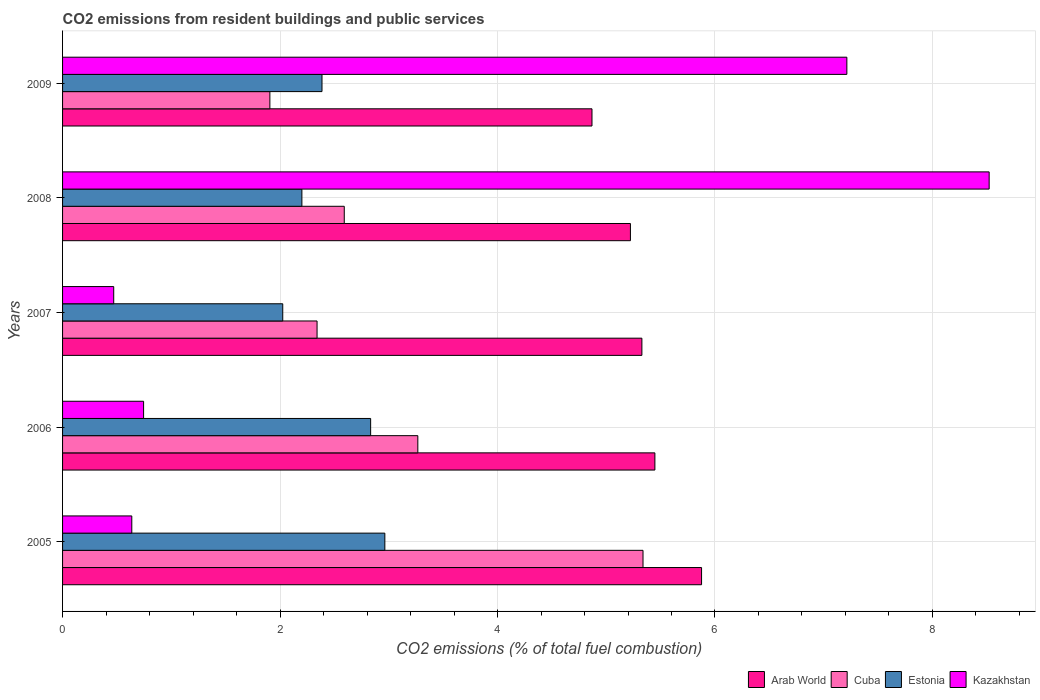How many different coloured bars are there?
Provide a succinct answer. 4. How many groups of bars are there?
Provide a succinct answer. 5. Are the number of bars per tick equal to the number of legend labels?
Provide a succinct answer. Yes. Are the number of bars on each tick of the Y-axis equal?
Offer a very short reply. Yes. How many bars are there on the 2nd tick from the top?
Your answer should be very brief. 4. In how many cases, is the number of bars for a given year not equal to the number of legend labels?
Offer a very short reply. 0. What is the total CO2 emitted in Arab World in 2008?
Keep it short and to the point. 5.22. Across all years, what is the maximum total CO2 emitted in Arab World?
Offer a very short reply. 5.88. Across all years, what is the minimum total CO2 emitted in Arab World?
Provide a short and direct response. 4.87. In which year was the total CO2 emitted in Kazakhstan maximum?
Provide a short and direct response. 2008. What is the total total CO2 emitted in Cuba in the graph?
Offer a terse response. 15.44. What is the difference between the total CO2 emitted in Arab World in 2005 and that in 2007?
Make the answer very short. 0.55. What is the difference between the total CO2 emitted in Estonia in 2009 and the total CO2 emitted in Cuba in 2007?
Your answer should be very brief. 0.05. What is the average total CO2 emitted in Arab World per year?
Offer a very short reply. 5.35. In the year 2009, what is the difference between the total CO2 emitted in Estonia and total CO2 emitted in Cuba?
Ensure brevity in your answer.  0.48. What is the ratio of the total CO2 emitted in Arab World in 2006 to that in 2008?
Provide a short and direct response. 1.04. Is the total CO2 emitted in Cuba in 2007 less than that in 2008?
Offer a terse response. Yes. Is the difference between the total CO2 emitted in Estonia in 2008 and 2009 greater than the difference between the total CO2 emitted in Cuba in 2008 and 2009?
Make the answer very short. No. What is the difference between the highest and the second highest total CO2 emitted in Kazakhstan?
Your answer should be very brief. 1.31. What is the difference between the highest and the lowest total CO2 emitted in Estonia?
Give a very brief answer. 0.94. In how many years, is the total CO2 emitted in Estonia greater than the average total CO2 emitted in Estonia taken over all years?
Provide a succinct answer. 2. Is it the case that in every year, the sum of the total CO2 emitted in Cuba and total CO2 emitted in Arab World is greater than the sum of total CO2 emitted in Kazakhstan and total CO2 emitted in Estonia?
Make the answer very short. Yes. What does the 2nd bar from the top in 2007 represents?
Your answer should be compact. Estonia. What does the 2nd bar from the bottom in 2009 represents?
Make the answer very short. Cuba. Is it the case that in every year, the sum of the total CO2 emitted in Estonia and total CO2 emitted in Kazakhstan is greater than the total CO2 emitted in Cuba?
Ensure brevity in your answer.  No. How many years are there in the graph?
Keep it short and to the point. 5. What is the difference between two consecutive major ticks on the X-axis?
Give a very brief answer. 2. Does the graph contain any zero values?
Give a very brief answer. No. Where does the legend appear in the graph?
Offer a terse response. Bottom right. What is the title of the graph?
Provide a short and direct response. CO2 emissions from resident buildings and public services. Does "Cyprus" appear as one of the legend labels in the graph?
Offer a very short reply. No. What is the label or title of the X-axis?
Give a very brief answer. CO2 emissions (% of total fuel combustion). What is the CO2 emissions (% of total fuel combustion) in Arab World in 2005?
Make the answer very short. 5.88. What is the CO2 emissions (% of total fuel combustion) of Cuba in 2005?
Ensure brevity in your answer.  5.34. What is the CO2 emissions (% of total fuel combustion) in Estonia in 2005?
Keep it short and to the point. 2.96. What is the CO2 emissions (% of total fuel combustion) in Kazakhstan in 2005?
Keep it short and to the point. 0.64. What is the CO2 emissions (% of total fuel combustion) of Arab World in 2006?
Give a very brief answer. 5.45. What is the CO2 emissions (% of total fuel combustion) of Cuba in 2006?
Offer a terse response. 3.27. What is the CO2 emissions (% of total fuel combustion) of Estonia in 2006?
Provide a short and direct response. 2.83. What is the CO2 emissions (% of total fuel combustion) in Kazakhstan in 2006?
Keep it short and to the point. 0.75. What is the CO2 emissions (% of total fuel combustion) of Arab World in 2007?
Offer a very short reply. 5.33. What is the CO2 emissions (% of total fuel combustion) in Cuba in 2007?
Your answer should be very brief. 2.34. What is the CO2 emissions (% of total fuel combustion) of Estonia in 2007?
Make the answer very short. 2.02. What is the CO2 emissions (% of total fuel combustion) of Kazakhstan in 2007?
Your answer should be very brief. 0.47. What is the CO2 emissions (% of total fuel combustion) of Arab World in 2008?
Provide a short and direct response. 5.22. What is the CO2 emissions (% of total fuel combustion) in Cuba in 2008?
Your answer should be compact. 2.59. What is the CO2 emissions (% of total fuel combustion) in Estonia in 2008?
Offer a terse response. 2.2. What is the CO2 emissions (% of total fuel combustion) of Kazakhstan in 2008?
Your answer should be compact. 8.52. What is the CO2 emissions (% of total fuel combustion) in Arab World in 2009?
Your answer should be compact. 4.87. What is the CO2 emissions (% of total fuel combustion) in Cuba in 2009?
Keep it short and to the point. 1.91. What is the CO2 emissions (% of total fuel combustion) of Estonia in 2009?
Offer a very short reply. 2.39. What is the CO2 emissions (% of total fuel combustion) of Kazakhstan in 2009?
Make the answer very short. 7.21. Across all years, what is the maximum CO2 emissions (% of total fuel combustion) of Arab World?
Give a very brief answer. 5.88. Across all years, what is the maximum CO2 emissions (% of total fuel combustion) in Cuba?
Provide a short and direct response. 5.34. Across all years, what is the maximum CO2 emissions (% of total fuel combustion) in Estonia?
Ensure brevity in your answer.  2.96. Across all years, what is the maximum CO2 emissions (% of total fuel combustion) of Kazakhstan?
Ensure brevity in your answer.  8.52. Across all years, what is the minimum CO2 emissions (% of total fuel combustion) of Arab World?
Your response must be concise. 4.87. Across all years, what is the minimum CO2 emissions (% of total fuel combustion) of Cuba?
Keep it short and to the point. 1.91. Across all years, what is the minimum CO2 emissions (% of total fuel combustion) of Estonia?
Provide a succinct answer. 2.02. Across all years, what is the minimum CO2 emissions (% of total fuel combustion) of Kazakhstan?
Your answer should be compact. 0.47. What is the total CO2 emissions (% of total fuel combustion) of Arab World in the graph?
Your response must be concise. 26.74. What is the total CO2 emissions (% of total fuel combustion) in Cuba in the graph?
Your response must be concise. 15.44. What is the total CO2 emissions (% of total fuel combustion) of Estonia in the graph?
Your answer should be very brief. 12.41. What is the total CO2 emissions (% of total fuel combustion) of Kazakhstan in the graph?
Your answer should be compact. 17.59. What is the difference between the CO2 emissions (% of total fuel combustion) in Arab World in 2005 and that in 2006?
Make the answer very short. 0.43. What is the difference between the CO2 emissions (% of total fuel combustion) in Cuba in 2005 and that in 2006?
Ensure brevity in your answer.  2.07. What is the difference between the CO2 emissions (% of total fuel combustion) in Estonia in 2005 and that in 2006?
Your response must be concise. 0.13. What is the difference between the CO2 emissions (% of total fuel combustion) of Kazakhstan in 2005 and that in 2006?
Offer a terse response. -0.11. What is the difference between the CO2 emissions (% of total fuel combustion) in Arab World in 2005 and that in 2007?
Give a very brief answer. 0.55. What is the difference between the CO2 emissions (% of total fuel combustion) of Cuba in 2005 and that in 2007?
Provide a short and direct response. 3. What is the difference between the CO2 emissions (% of total fuel combustion) of Estonia in 2005 and that in 2007?
Your answer should be very brief. 0.94. What is the difference between the CO2 emissions (% of total fuel combustion) in Kazakhstan in 2005 and that in 2007?
Your answer should be very brief. 0.17. What is the difference between the CO2 emissions (% of total fuel combustion) of Arab World in 2005 and that in 2008?
Provide a succinct answer. 0.65. What is the difference between the CO2 emissions (% of total fuel combustion) of Cuba in 2005 and that in 2008?
Keep it short and to the point. 2.75. What is the difference between the CO2 emissions (% of total fuel combustion) of Estonia in 2005 and that in 2008?
Keep it short and to the point. 0.76. What is the difference between the CO2 emissions (% of total fuel combustion) in Kazakhstan in 2005 and that in 2008?
Offer a very short reply. -7.88. What is the difference between the CO2 emissions (% of total fuel combustion) in Arab World in 2005 and that in 2009?
Offer a very short reply. 1.01. What is the difference between the CO2 emissions (% of total fuel combustion) of Cuba in 2005 and that in 2009?
Ensure brevity in your answer.  3.43. What is the difference between the CO2 emissions (% of total fuel combustion) in Estonia in 2005 and that in 2009?
Your response must be concise. 0.58. What is the difference between the CO2 emissions (% of total fuel combustion) in Kazakhstan in 2005 and that in 2009?
Give a very brief answer. -6.58. What is the difference between the CO2 emissions (% of total fuel combustion) of Arab World in 2006 and that in 2007?
Your response must be concise. 0.12. What is the difference between the CO2 emissions (% of total fuel combustion) of Cuba in 2006 and that in 2007?
Offer a very short reply. 0.93. What is the difference between the CO2 emissions (% of total fuel combustion) of Estonia in 2006 and that in 2007?
Your response must be concise. 0.81. What is the difference between the CO2 emissions (% of total fuel combustion) in Kazakhstan in 2006 and that in 2007?
Make the answer very short. 0.27. What is the difference between the CO2 emissions (% of total fuel combustion) of Arab World in 2006 and that in 2008?
Offer a very short reply. 0.23. What is the difference between the CO2 emissions (% of total fuel combustion) of Cuba in 2006 and that in 2008?
Offer a very short reply. 0.68. What is the difference between the CO2 emissions (% of total fuel combustion) in Estonia in 2006 and that in 2008?
Keep it short and to the point. 0.63. What is the difference between the CO2 emissions (% of total fuel combustion) in Kazakhstan in 2006 and that in 2008?
Your answer should be compact. -7.78. What is the difference between the CO2 emissions (% of total fuel combustion) in Arab World in 2006 and that in 2009?
Offer a very short reply. 0.58. What is the difference between the CO2 emissions (% of total fuel combustion) in Cuba in 2006 and that in 2009?
Give a very brief answer. 1.36. What is the difference between the CO2 emissions (% of total fuel combustion) in Estonia in 2006 and that in 2009?
Give a very brief answer. 0.45. What is the difference between the CO2 emissions (% of total fuel combustion) of Kazakhstan in 2006 and that in 2009?
Ensure brevity in your answer.  -6.47. What is the difference between the CO2 emissions (% of total fuel combustion) in Arab World in 2007 and that in 2008?
Offer a very short reply. 0.11. What is the difference between the CO2 emissions (% of total fuel combustion) of Cuba in 2007 and that in 2008?
Your response must be concise. -0.25. What is the difference between the CO2 emissions (% of total fuel combustion) in Estonia in 2007 and that in 2008?
Give a very brief answer. -0.18. What is the difference between the CO2 emissions (% of total fuel combustion) of Kazakhstan in 2007 and that in 2008?
Keep it short and to the point. -8.05. What is the difference between the CO2 emissions (% of total fuel combustion) of Arab World in 2007 and that in 2009?
Your answer should be very brief. 0.46. What is the difference between the CO2 emissions (% of total fuel combustion) in Cuba in 2007 and that in 2009?
Provide a succinct answer. 0.43. What is the difference between the CO2 emissions (% of total fuel combustion) in Estonia in 2007 and that in 2009?
Offer a very short reply. -0.36. What is the difference between the CO2 emissions (% of total fuel combustion) in Kazakhstan in 2007 and that in 2009?
Give a very brief answer. -6.74. What is the difference between the CO2 emissions (% of total fuel combustion) in Arab World in 2008 and that in 2009?
Your answer should be very brief. 0.35. What is the difference between the CO2 emissions (% of total fuel combustion) of Cuba in 2008 and that in 2009?
Keep it short and to the point. 0.68. What is the difference between the CO2 emissions (% of total fuel combustion) of Estonia in 2008 and that in 2009?
Provide a short and direct response. -0.18. What is the difference between the CO2 emissions (% of total fuel combustion) of Kazakhstan in 2008 and that in 2009?
Keep it short and to the point. 1.31. What is the difference between the CO2 emissions (% of total fuel combustion) of Arab World in 2005 and the CO2 emissions (% of total fuel combustion) of Cuba in 2006?
Provide a succinct answer. 2.61. What is the difference between the CO2 emissions (% of total fuel combustion) in Arab World in 2005 and the CO2 emissions (% of total fuel combustion) in Estonia in 2006?
Provide a short and direct response. 3.04. What is the difference between the CO2 emissions (% of total fuel combustion) in Arab World in 2005 and the CO2 emissions (% of total fuel combustion) in Kazakhstan in 2006?
Provide a succinct answer. 5.13. What is the difference between the CO2 emissions (% of total fuel combustion) of Cuba in 2005 and the CO2 emissions (% of total fuel combustion) of Estonia in 2006?
Offer a very short reply. 2.5. What is the difference between the CO2 emissions (% of total fuel combustion) of Cuba in 2005 and the CO2 emissions (% of total fuel combustion) of Kazakhstan in 2006?
Keep it short and to the point. 4.59. What is the difference between the CO2 emissions (% of total fuel combustion) in Estonia in 2005 and the CO2 emissions (% of total fuel combustion) in Kazakhstan in 2006?
Ensure brevity in your answer.  2.22. What is the difference between the CO2 emissions (% of total fuel combustion) in Arab World in 2005 and the CO2 emissions (% of total fuel combustion) in Cuba in 2007?
Give a very brief answer. 3.54. What is the difference between the CO2 emissions (% of total fuel combustion) of Arab World in 2005 and the CO2 emissions (% of total fuel combustion) of Estonia in 2007?
Ensure brevity in your answer.  3.85. What is the difference between the CO2 emissions (% of total fuel combustion) in Arab World in 2005 and the CO2 emissions (% of total fuel combustion) in Kazakhstan in 2007?
Provide a succinct answer. 5.41. What is the difference between the CO2 emissions (% of total fuel combustion) in Cuba in 2005 and the CO2 emissions (% of total fuel combustion) in Estonia in 2007?
Provide a succinct answer. 3.31. What is the difference between the CO2 emissions (% of total fuel combustion) in Cuba in 2005 and the CO2 emissions (% of total fuel combustion) in Kazakhstan in 2007?
Give a very brief answer. 4.87. What is the difference between the CO2 emissions (% of total fuel combustion) in Estonia in 2005 and the CO2 emissions (% of total fuel combustion) in Kazakhstan in 2007?
Provide a short and direct response. 2.49. What is the difference between the CO2 emissions (% of total fuel combustion) in Arab World in 2005 and the CO2 emissions (% of total fuel combustion) in Cuba in 2008?
Keep it short and to the point. 3.29. What is the difference between the CO2 emissions (% of total fuel combustion) in Arab World in 2005 and the CO2 emissions (% of total fuel combustion) in Estonia in 2008?
Ensure brevity in your answer.  3.68. What is the difference between the CO2 emissions (% of total fuel combustion) of Arab World in 2005 and the CO2 emissions (% of total fuel combustion) of Kazakhstan in 2008?
Give a very brief answer. -2.65. What is the difference between the CO2 emissions (% of total fuel combustion) in Cuba in 2005 and the CO2 emissions (% of total fuel combustion) in Estonia in 2008?
Ensure brevity in your answer.  3.14. What is the difference between the CO2 emissions (% of total fuel combustion) of Cuba in 2005 and the CO2 emissions (% of total fuel combustion) of Kazakhstan in 2008?
Provide a succinct answer. -3.18. What is the difference between the CO2 emissions (% of total fuel combustion) in Estonia in 2005 and the CO2 emissions (% of total fuel combustion) in Kazakhstan in 2008?
Your response must be concise. -5.56. What is the difference between the CO2 emissions (% of total fuel combustion) in Arab World in 2005 and the CO2 emissions (% of total fuel combustion) in Cuba in 2009?
Your answer should be very brief. 3.97. What is the difference between the CO2 emissions (% of total fuel combustion) in Arab World in 2005 and the CO2 emissions (% of total fuel combustion) in Estonia in 2009?
Keep it short and to the point. 3.49. What is the difference between the CO2 emissions (% of total fuel combustion) of Arab World in 2005 and the CO2 emissions (% of total fuel combustion) of Kazakhstan in 2009?
Provide a short and direct response. -1.34. What is the difference between the CO2 emissions (% of total fuel combustion) of Cuba in 2005 and the CO2 emissions (% of total fuel combustion) of Estonia in 2009?
Ensure brevity in your answer.  2.95. What is the difference between the CO2 emissions (% of total fuel combustion) in Cuba in 2005 and the CO2 emissions (% of total fuel combustion) in Kazakhstan in 2009?
Give a very brief answer. -1.87. What is the difference between the CO2 emissions (% of total fuel combustion) in Estonia in 2005 and the CO2 emissions (% of total fuel combustion) in Kazakhstan in 2009?
Offer a very short reply. -4.25. What is the difference between the CO2 emissions (% of total fuel combustion) of Arab World in 2006 and the CO2 emissions (% of total fuel combustion) of Cuba in 2007?
Your answer should be compact. 3.11. What is the difference between the CO2 emissions (% of total fuel combustion) in Arab World in 2006 and the CO2 emissions (% of total fuel combustion) in Estonia in 2007?
Provide a succinct answer. 3.42. What is the difference between the CO2 emissions (% of total fuel combustion) of Arab World in 2006 and the CO2 emissions (% of total fuel combustion) of Kazakhstan in 2007?
Give a very brief answer. 4.98. What is the difference between the CO2 emissions (% of total fuel combustion) of Cuba in 2006 and the CO2 emissions (% of total fuel combustion) of Estonia in 2007?
Give a very brief answer. 1.24. What is the difference between the CO2 emissions (% of total fuel combustion) of Cuba in 2006 and the CO2 emissions (% of total fuel combustion) of Kazakhstan in 2007?
Your answer should be very brief. 2.8. What is the difference between the CO2 emissions (% of total fuel combustion) of Estonia in 2006 and the CO2 emissions (% of total fuel combustion) of Kazakhstan in 2007?
Give a very brief answer. 2.36. What is the difference between the CO2 emissions (% of total fuel combustion) of Arab World in 2006 and the CO2 emissions (% of total fuel combustion) of Cuba in 2008?
Offer a very short reply. 2.86. What is the difference between the CO2 emissions (% of total fuel combustion) of Arab World in 2006 and the CO2 emissions (% of total fuel combustion) of Estonia in 2008?
Your answer should be very brief. 3.25. What is the difference between the CO2 emissions (% of total fuel combustion) of Arab World in 2006 and the CO2 emissions (% of total fuel combustion) of Kazakhstan in 2008?
Your answer should be compact. -3.07. What is the difference between the CO2 emissions (% of total fuel combustion) in Cuba in 2006 and the CO2 emissions (% of total fuel combustion) in Estonia in 2008?
Offer a very short reply. 1.07. What is the difference between the CO2 emissions (% of total fuel combustion) of Cuba in 2006 and the CO2 emissions (% of total fuel combustion) of Kazakhstan in 2008?
Your answer should be compact. -5.25. What is the difference between the CO2 emissions (% of total fuel combustion) in Estonia in 2006 and the CO2 emissions (% of total fuel combustion) in Kazakhstan in 2008?
Ensure brevity in your answer.  -5.69. What is the difference between the CO2 emissions (% of total fuel combustion) in Arab World in 2006 and the CO2 emissions (% of total fuel combustion) in Cuba in 2009?
Your answer should be compact. 3.54. What is the difference between the CO2 emissions (% of total fuel combustion) of Arab World in 2006 and the CO2 emissions (% of total fuel combustion) of Estonia in 2009?
Ensure brevity in your answer.  3.06. What is the difference between the CO2 emissions (% of total fuel combustion) in Arab World in 2006 and the CO2 emissions (% of total fuel combustion) in Kazakhstan in 2009?
Give a very brief answer. -1.77. What is the difference between the CO2 emissions (% of total fuel combustion) of Cuba in 2006 and the CO2 emissions (% of total fuel combustion) of Estonia in 2009?
Make the answer very short. 0.88. What is the difference between the CO2 emissions (% of total fuel combustion) of Cuba in 2006 and the CO2 emissions (% of total fuel combustion) of Kazakhstan in 2009?
Your response must be concise. -3.95. What is the difference between the CO2 emissions (% of total fuel combustion) of Estonia in 2006 and the CO2 emissions (% of total fuel combustion) of Kazakhstan in 2009?
Offer a very short reply. -4.38. What is the difference between the CO2 emissions (% of total fuel combustion) in Arab World in 2007 and the CO2 emissions (% of total fuel combustion) in Cuba in 2008?
Keep it short and to the point. 2.74. What is the difference between the CO2 emissions (% of total fuel combustion) in Arab World in 2007 and the CO2 emissions (% of total fuel combustion) in Estonia in 2008?
Ensure brevity in your answer.  3.13. What is the difference between the CO2 emissions (% of total fuel combustion) of Arab World in 2007 and the CO2 emissions (% of total fuel combustion) of Kazakhstan in 2008?
Provide a succinct answer. -3.19. What is the difference between the CO2 emissions (% of total fuel combustion) in Cuba in 2007 and the CO2 emissions (% of total fuel combustion) in Estonia in 2008?
Your response must be concise. 0.14. What is the difference between the CO2 emissions (% of total fuel combustion) of Cuba in 2007 and the CO2 emissions (% of total fuel combustion) of Kazakhstan in 2008?
Offer a terse response. -6.18. What is the difference between the CO2 emissions (% of total fuel combustion) in Estonia in 2007 and the CO2 emissions (% of total fuel combustion) in Kazakhstan in 2008?
Provide a succinct answer. -6.5. What is the difference between the CO2 emissions (% of total fuel combustion) in Arab World in 2007 and the CO2 emissions (% of total fuel combustion) in Cuba in 2009?
Your response must be concise. 3.42. What is the difference between the CO2 emissions (% of total fuel combustion) of Arab World in 2007 and the CO2 emissions (% of total fuel combustion) of Estonia in 2009?
Your response must be concise. 2.94. What is the difference between the CO2 emissions (% of total fuel combustion) of Arab World in 2007 and the CO2 emissions (% of total fuel combustion) of Kazakhstan in 2009?
Give a very brief answer. -1.89. What is the difference between the CO2 emissions (% of total fuel combustion) in Cuba in 2007 and the CO2 emissions (% of total fuel combustion) in Estonia in 2009?
Provide a short and direct response. -0.05. What is the difference between the CO2 emissions (% of total fuel combustion) of Cuba in 2007 and the CO2 emissions (% of total fuel combustion) of Kazakhstan in 2009?
Provide a short and direct response. -4.87. What is the difference between the CO2 emissions (% of total fuel combustion) in Estonia in 2007 and the CO2 emissions (% of total fuel combustion) in Kazakhstan in 2009?
Provide a short and direct response. -5.19. What is the difference between the CO2 emissions (% of total fuel combustion) of Arab World in 2008 and the CO2 emissions (% of total fuel combustion) of Cuba in 2009?
Offer a very short reply. 3.32. What is the difference between the CO2 emissions (% of total fuel combustion) in Arab World in 2008 and the CO2 emissions (% of total fuel combustion) in Estonia in 2009?
Keep it short and to the point. 2.84. What is the difference between the CO2 emissions (% of total fuel combustion) in Arab World in 2008 and the CO2 emissions (% of total fuel combustion) in Kazakhstan in 2009?
Your response must be concise. -1.99. What is the difference between the CO2 emissions (% of total fuel combustion) of Cuba in 2008 and the CO2 emissions (% of total fuel combustion) of Estonia in 2009?
Make the answer very short. 0.2. What is the difference between the CO2 emissions (% of total fuel combustion) in Cuba in 2008 and the CO2 emissions (% of total fuel combustion) in Kazakhstan in 2009?
Provide a succinct answer. -4.62. What is the difference between the CO2 emissions (% of total fuel combustion) in Estonia in 2008 and the CO2 emissions (% of total fuel combustion) in Kazakhstan in 2009?
Offer a very short reply. -5.01. What is the average CO2 emissions (% of total fuel combustion) in Arab World per year?
Offer a very short reply. 5.35. What is the average CO2 emissions (% of total fuel combustion) in Cuba per year?
Your answer should be very brief. 3.09. What is the average CO2 emissions (% of total fuel combustion) of Estonia per year?
Make the answer very short. 2.48. What is the average CO2 emissions (% of total fuel combustion) in Kazakhstan per year?
Offer a very short reply. 3.52. In the year 2005, what is the difference between the CO2 emissions (% of total fuel combustion) of Arab World and CO2 emissions (% of total fuel combustion) of Cuba?
Your answer should be compact. 0.54. In the year 2005, what is the difference between the CO2 emissions (% of total fuel combustion) in Arab World and CO2 emissions (% of total fuel combustion) in Estonia?
Ensure brevity in your answer.  2.91. In the year 2005, what is the difference between the CO2 emissions (% of total fuel combustion) of Arab World and CO2 emissions (% of total fuel combustion) of Kazakhstan?
Ensure brevity in your answer.  5.24. In the year 2005, what is the difference between the CO2 emissions (% of total fuel combustion) of Cuba and CO2 emissions (% of total fuel combustion) of Estonia?
Your response must be concise. 2.37. In the year 2005, what is the difference between the CO2 emissions (% of total fuel combustion) of Cuba and CO2 emissions (% of total fuel combustion) of Kazakhstan?
Ensure brevity in your answer.  4.7. In the year 2005, what is the difference between the CO2 emissions (% of total fuel combustion) in Estonia and CO2 emissions (% of total fuel combustion) in Kazakhstan?
Offer a terse response. 2.33. In the year 2006, what is the difference between the CO2 emissions (% of total fuel combustion) in Arab World and CO2 emissions (% of total fuel combustion) in Cuba?
Ensure brevity in your answer.  2.18. In the year 2006, what is the difference between the CO2 emissions (% of total fuel combustion) in Arab World and CO2 emissions (% of total fuel combustion) in Estonia?
Keep it short and to the point. 2.61. In the year 2006, what is the difference between the CO2 emissions (% of total fuel combustion) of Arab World and CO2 emissions (% of total fuel combustion) of Kazakhstan?
Make the answer very short. 4.7. In the year 2006, what is the difference between the CO2 emissions (% of total fuel combustion) of Cuba and CO2 emissions (% of total fuel combustion) of Estonia?
Ensure brevity in your answer.  0.43. In the year 2006, what is the difference between the CO2 emissions (% of total fuel combustion) in Cuba and CO2 emissions (% of total fuel combustion) in Kazakhstan?
Your answer should be compact. 2.52. In the year 2006, what is the difference between the CO2 emissions (% of total fuel combustion) in Estonia and CO2 emissions (% of total fuel combustion) in Kazakhstan?
Make the answer very short. 2.09. In the year 2007, what is the difference between the CO2 emissions (% of total fuel combustion) of Arab World and CO2 emissions (% of total fuel combustion) of Cuba?
Provide a short and direct response. 2.99. In the year 2007, what is the difference between the CO2 emissions (% of total fuel combustion) of Arab World and CO2 emissions (% of total fuel combustion) of Estonia?
Make the answer very short. 3.3. In the year 2007, what is the difference between the CO2 emissions (% of total fuel combustion) in Arab World and CO2 emissions (% of total fuel combustion) in Kazakhstan?
Offer a terse response. 4.86. In the year 2007, what is the difference between the CO2 emissions (% of total fuel combustion) of Cuba and CO2 emissions (% of total fuel combustion) of Estonia?
Your answer should be compact. 0.32. In the year 2007, what is the difference between the CO2 emissions (% of total fuel combustion) in Cuba and CO2 emissions (% of total fuel combustion) in Kazakhstan?
Give a very brief answer. 1.87. In the year 2007, what is the difference between the CO2 emissions (% of total fuel combustion) in Estonia and CO2 emissions (% of total fuel combustion) in Kazakhstan?
Your response must be concise. 1.55. In the year 2008, what is the difference between the CO2 emissions (% of total fuel combustion) of Arab World and CO2 emissions (% of total fuel combustion) of Cuba?
Offer a very short reply. 2.63. In the year 2008, what is the difference between the CO2 emissions (% of total fuel combustion) in Arab World and CO2 emissions (% of total fuel combustion) in Estonia?
Offer a very short reply. 3.02. In the year 2008, what is the difference between the CO2 emissions (% of total fuel combustion) of Arab World and CO2 emissions (% of total fuel combustion) of Kazakhstan?
Your response must be concise. -3.3. In the year 2008, what is the difference between the CO2 emissions (% of total fuel combustion) in Cuba and CO2 emissions (% of total fuel combustion) in Estonia?
Give a very brief answer. 0.39. In the year 2008, what is the difference between the CO2 emissions (% of total fuel combustion) in Cuba and CO2 emissions (% of total fuel combustion) in Kazakhstan?
Your answer should be compact. -5.93. In the year 2008, what is the difference between the CO2 emissions (% of total fuel combustion) of Estonia and CO2 emissions (% of total fuel combustion) of Kazakhstan?
Offer a very short reply. -6.32. In the year 2009, what is the difference between the CO2 emissions (% of total fuel combustion) of Arab World and CO2 emissions (% of total fuel combustion) of Cuba?
Provide a succinct answer. 2.96. In the year 2009, what is the difference between the CO2 emissions (% of total fuel combustion) of Arab World and CO2 emissions (% of total fuel combustion) of Estonia?
Your answer should be compact. 2.48. In the year 2009, what is the difference between the CO2 emissions (% of total fuel combustion) of Arab World and CO2 emissions (% of total fuel combustion) of Kazakhstan?
Your response must be concise. -2.34. In the year 2009, what is the difference between the CO2 emissions (% of total fuel combustion) of Cuba and CO2 emissions (% of total fuel combustion) of Estonia?
Keep it short and to the point. -0.48. In the year 2009, what is the difference between the CO2 emissions (% of total fuel combustion) in Cuba and CO2 emissions (% of total fuel combustion) in Kazakhstan?
Make the answer very short. -5.31. In the year 2009, what is the difference between the CO2 emissions (% of total fuel combustion) in Estonia and CO2 emissions (% of total fuel combustion) in Kazakhstan?
Your answer should be very brief. -4.83. What is the ratio of the CO2 emissions (% of total fuel combustion) in Arab World in 2005 to that in 2006?
Your answer should be compact. 1.08. What is the ratio of the CO2 emissions (% of total fuel combustion) of Cuba in 2005 to that in 2006?
Your response must be concise. 1.63. What is the ratio of the CO2 emissions (% of total fuel combustion) of Estonia in 2005 to that in 2006?
Provide a succinct answer. 1.05. What is the ratio of the CO2 emissions (% of total fuel combustion) in Kazakhstan in 2005 to that in 2006?
Keep it short and to the point. 0.85. What is the ratio of the CO2 emissions (% of total fuel combustion) of Arab World in 2005 to that in 2007?
Your answer should be very brief. 1.1. What is the ratio of the CO2 emissions (% of total fuel combustion) of Cuba in 2005 to that in 2007?
Make the answer very short. 2.28. What is the ratio of the CO2 emissions (% of total fuel combustion) in Estonia in 2005 to that in 2007?
Offer a terse response. 1.46. What is the ratio of the CO2 emissions (% of total fuel combustion) of Kazakhstan in 2005 to that in 2007?
Provide a short and direct response. 1.35. What is the ratio of the CO2 emissions (% of total fuel combustion) in Arab World in 2005 to that in 2008?
Your answer should be very brief. 1.13. What is the ratio of the CO2 emissions (% of total fuel combustion) in Cuba in 2005 to that in 2008?
Ensure brevity in your answer.  2.06. What is the ratio of the CO2 emissions (% of total fuel combustion) of Estonia in 2005 to that in 2008?
Offer a terse response. 1.35. What is the ratio of the CO2 emissions (% of total fuel combustion) in Kazakhstan in 2005 to that in 2008?
Your response must be concise. 0.07. What is the ratio of the CO2 emissions (% of total fuel combustion) of Arab World in 2005 to that in 2009?
Keep it short and to the point. 1.21. What is the ratio of the CO2 emissions (% of total fuel combustion) of Cuba in 2005 to that in 2009?
Offer a very short reply. 2.8. What is the ratio of the CO2 emissions (% of total fuel combustion) of Estonia in 2005 to that in 2009?
Your response must be concise. 1.24. What is the ratio of the CO2 emissions (% of total fuel combustion) of Kazakhstan in 2005 to that in 2009?
Your response must be concise. 0.09. What is the ratio of the CO2 emissions (% of total fuel combustion) of Arab World in 2006 to that in 2007?
Provide a succinct answer. 1.02. What is the ratio of the CO2 emissions (% of total fuel combustion) in Cuba in 2006 to that in 2007?
Keep it short and to the point. 1.4. What is the ratio of the CO2 emissions (% of total fuel combustion) in Estonia in 2006 to that in 2007?
Your answer should be compact. 1.4. What is the ratio of the CO2 emissions (% of total fuel combustion) of Kazakhstan in 2006 to that in 2007?
Make the answer very short. 1.58. What is the ratio of the CO2 emissions (% of total fuel combustion) in Arab World in 2006 to that in 2008?
Provide a succinct answer. 1.04. What is the ratio of the CO2 emissions (% of total fuel combustion) in Cuba in 2006 to that in 2008?
Offer a very short reply. 1.26. What is the ratio of the CO2 emissions (% of total fuel combustion) of Estonia in 2006 to that in 2008?
Offer a terse response. 1.29. What is the ratio of the CO2 emissions (% of total fuel combustion) of Kazakhstan in 2006 to that in 2008?
Your answer should be very brief. 0.09. What is the ratio of the CO2 emissions (% of total fuel combustion) of Arab World in 2006 to that in 2009?
Ensure brevity in your answer.  1.12. What is the ratio of the CO2 emissions (% of total fuel combustion) in Cuba in 2006 to that in 2009?
Your response must be concise. 1.71. What is the ratio of the CO2 emissions (% of total fuel combustion) in Estonia in 2006 to that in 2009?
Your answer should be very brief. 1.19. What is the ratio of the CO2 emissions (% of total fuel combustion) in Kazakhstan in 2006 to that in 2009?
Your response must be concise. 0.1. What is the ratio of the CO2 emissions (% of total fuel combustion) of Arab World in 2007 to that in 2008?
Make the answer very short. 1.02. What is the ratio of the CO2 emissions (% of total fuel combustion) in Cuba in 2007 to that in 2008?
Your answer should be compact. 0.9. What is the ratio of the CO2 emissions (% of total fuel combustion) of Kazakhstan in 2007 to that in 2008?
Your response must be concise. 0.06. What is the ratio of the CO2 emissions (% of total fuel combustion) of Arab World in 2007 to that in 2009?
Give a very brief answer. 1.09. What is the ratio of the CO2 emissions (% of total fuel combustion) in Cuba in 2007 to that in 2009?
Give a very brief answer. 1.23. What is the ratio of the CO2 emissions (% of total fuel combustion) in Estonia in 2007 to that in 2009?
Provide a succinct answer. 0.85. What is the ratio of the CO2 emissions (% of total fuel combustion) of Kazakhstan in 2007 to that in 2009?
Keep it short and to the point. 0.07. What is the ratio of the CO2 emissions (% of total fuel combustion) in Arab World in 2008 to that in 2009?
Offer a terse response. 1.07. What is the ratio of the CO2 emissions (% of total fuel combustion) in Cuba in 2008 to that in 2009?
Offer a terse response. 1.36. What is the ratio of the CO2 emissions (% of total fuel combustion) of Estonia in 2008 to that in 2009?
Ensure brevity in your answer.  0.92. What is the ratio of the CO2 emissions (% of total fuel combustion) of Kazakhstan in 2008 to that in 2009?
Provide a short and direct response. 1.18. What is the difference between the highest and the second highest CO2 emissions (% of total fuel combustion) in Arab World?
Make the answer very short. 0.43. What is the difference between the highest and the second highest CO2 emissions (% of total fuel combustion) in Cuba?
Your response must be concise. 2.07. What is the difference between the highest and the second highest CO2 emissions (% of total fuel combustion) of Estonia?
Provide a short and direct response. 0.13. What is the difference between the highest and the second highest CO2 emissions (% of total fuel combustion) in Kazakhstan?
Offer a terse response. 1.31. What is the difference between the highest and the lowest CO2 emissions (% of total fuel combustion) in Arab World?
Make the answer very short. 1.01. What is the difference between the highest and the lowest CO2 emissions (% of total fuel combustion) in Cuba?
Provide a short and direct response. 3.43. What is the difference between the highest and the lowest CO2 emissions (% of total fuel combustion) of Estonia?
Your answer should be compact. 0.94. What is the difference between the highest and the lowest CO2 emissions (% of total fuel combustion) of Kazakhstan?
Ensure brevity in your answer.  8.05. 